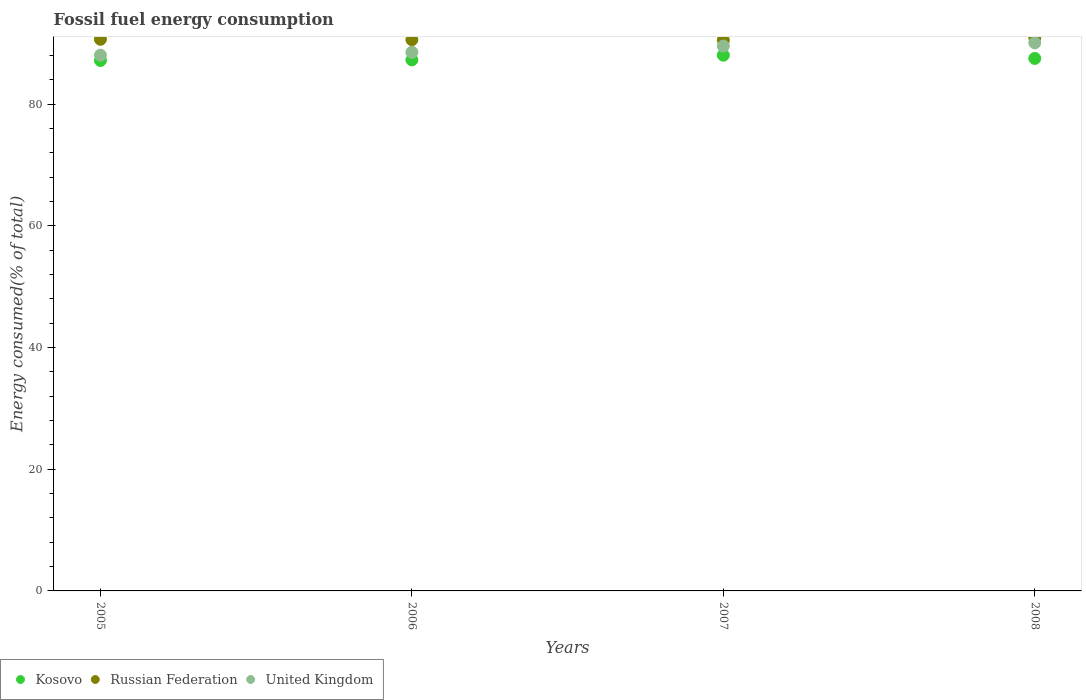Is the number of dotlines equal to the number of legend labels?
Give a very brief answer. Yes. What is the percentage of energy consumed in United Kingdom in 2008?
Your answer should be compact. 90.1. Across all years, what is the maximum percentage of energy consumed in Russian Federation?
Make the answer very short. 90.95. Across all years, what is the minimum percentage of energy consumed in Russian Federation?
Provide a short and direct response. 90.55. In which year was the percentage of energy consumed in United Kingdom maximum?
Offer a terse response. 2008. In which year was the percentage of energy consumed in Russian Federation minimum?
Keep it short and to the point. 2007. What is the total percentage of energy consumed in Russian Federation in the graph?
Ensure brevity in your answer.  362.81. What is the difference between the percentage of energy consumed in United Kingdom in 2005 and that in 2008?
Your answer should be compact. -2.03. What is the difference between the percentage of energy consumed in United Kingdom in 2006 and the percentage of energy consumed in Kosovo in 2007?
Keep it short and to the point. 0.47. What is the average percentage of energy consumed in Russian Federation per year?
Offer a terse response. 90.7. In the year 2005, what is the difference between the percentage of energy consumed in Russian Federation and percentage of energy consumed in Kosovo?
Your answer should be compact. 3.48. What is the ratio of the percentage of energy consumed in United Kingdom in 2006 to that in 2007?
Your response must be concise. 0.99. What is the difference between the highest and the second highest percentage of energy consumed in Russian Federation?
Your answer should be very brief. 0.26. What is the difference between the highest and the lowest percentage of energy consumed in Russian Federation?
Provide a succinct answer. 0.4. Is the sum of the percentage of energy consumed in United Kingdom in 2005 and 2007 greater than the maximum percentage of energy consumed in Kosovo across all years?
Make the answer very short. Yes. Is it the case that in every year, the sum of the percentage of energy consumed in Russian Federation and percentage of energy consumed in Kosovo  is greater than the percentage of energy consumed in United Kingdom?
Make the answer very short. Yes. Does the percentage of energy consumed in Russian Federation monotonically increase over the years?
Your answer should be compact. No. Is the percentage of energy consumed in United Kingdom strictly greater than the percentage of energy consumed in Russian Federation over the years?
Make the answer very short. No. Is the percentage of energy consumed in Kosovo strictly less than the percentage of energy consumed in Russian Federation over the years?
Keep it short and to the point. Yes. How many dotlines are there?
Make the answer very short. 3. How many years are there in the graph?
Your response must be concise. 4. Are the values on the major ticks of Y-axis written in scientific E-notation?
Give a very brief answer. No. How are the legend labels stacked?
Make the answer very short. Horizontal. What is the title of the graph?
Give a very brief answer. Fossil fuel energy consumption. Does "High income: OECD" appear as one of the legend labels in the graph?
Offer a terse response. No. What is the label or title of the Y-axis?
Offer a very short reply. Energy consumed(% of total). What is the Energy consumed(% of total) in Kosovo in 2005?
Your answer should be very brief. 87.21. What is the Energy consumed(% of total) in Russian Federation in 2005?
Keep it short and to the point. 90.69. What is the Energy consumed(% of total) of United Kingdom in 2005?
Provide a succinct answer. 88.08. What is the Energy consumed(% of total) of Kosovo in 2006?
Offer a very short reply. 87.3. What is the Energy consumed(% of total) in Russian Federation in 2006?
Give a very brief answer. 90.62. What is the Energy consumed(% of total) of United Kingdom in 2006?
Give a very brief answer. 88.55. What is the Energy consumed(% of total) in Kosovo in 2007?
Your answer should be compact. 88.07. What is the Energy consumed(% of total) of Russian Federation in 2007?
Your answer should be very brief. 90.55. What is the Energy consumed(% of total) of United Kingdom in 2007?
Your response must be concise. 89.58. What is the Energy consumed(% of total) in Kosovo in 2008?
Your answer should be very brief. 87.54. What is the Energy consumed(% of total) of Russian Federation in 2008?
Give a very brief answer. 90.95. What is the Energy consumed(% of total) of United Kingdom in 2008?
Your response must be concise. 90.1. Across all years, what is the maximum Energy consumed(% of total) of Kosovo?
Provide a short and direct response. 88.07. Across all years, what is the maximum Energy consumed(% of total) of Russian Federation?
Ensure brevity in your answer.  90.95. Across all years, what is the maximum Energy consumed(% of total) in United Kingdom?
Give a very brief answer. 90.1. Across all years, what is the minimum Energy consumed(% of total) in Kosovo?
Your response must be concise. 87.21. Across all years, what is the minimum Energy consumed(% of total) in Russian Federation?
Offer a very short reply. 90.55. Across all years, what is the minimum Energy consumed(% of total) in United Kingdom?
Make the answer very short. 88.08. What is the total Energy consumed(% of total) of Kosovo in the graph?
Ensure brevity in your answer.  350.12. What is the total Energy consumed(% of total) in Russian Federation in the graph?
Provide a short and direct response. 362.81. What is the total Energy consumed(% of total) in United Kingdom in the graph?
Offer a terse response. 356.3. What is the difference between the Energy consumed(% of total) in Kosovo in 2005 and that in 2006?
Ensure brevity in your answer.  -0.09. What is the difference between the Energy consumed(% of total) in Russian Federation in 2005 and that in 2006?
Offer a terse response. 0.07. What is the difference between the Energy consumed(% of total) of United Kingdom in 2005 and that in 2006?
Offer a terse response. -0.47. What is the difference between the Energy consumed(% of total) in Kosovo in 2005 and that in 2007?
Keep it short and to the point. -0.87. What is the difference between the Energy consumed(% of total) of Russian Federation in 2005 and that in 2007?
Make the answer very short. 0.14. What is the difference between the Energy consumed(% of total) in United Kingdom in 2005 and that in 2007?
Provide a succinct answer. -1.5. What is the difference between the Energy consumed(% of total) in Kosovo in 2005 and that in 2008?
Give a very brief answer. -0.33. What is the difference between the Energy consumed(% of total) of Russian Federation in 2005 and that in 2008?
Keep it short and to the point. -0.26. What is the difference between the Energy consumed(% of total) in United Kingdom in 2005 and that in 2008?
Offer a very short reply. -2.02. What is the difference between the Energy consumed(% of total) in Kosovo in 2006 and that in 2007?
Give a very brief answer. -0.77. What is the difference between the Energy consumed(% of total) in Russian Federation in 2006 and that in 2007?
Offer a very short reply. 0.07. What is the difference between the Energy consumed(% of total) in United Kingdom in 2006 and that in 2007?
Offer a terse response. -1.03. What is the difference between the Energy consumed(% of total) in Kosovo in 2006 and that in 2008?
Provide a succinct answer. -0.24. What is the difference between the Energy consumed(% of total) in Russian Federation in 2006 and that in 2008?
Give a very brief answer. -0.33. What is the difference between the Energy consumed(% of total) of United Kingdom in 2006 and that in 2008?
Your response must be concise. -1.55. What is the difference between the Energy consumed(% of total) of Kosovo in 2007 and that in 2008?
Provide a succinct answer. 0.53. What is the difference between the Energy consumed(% of total) in Russian Federation in 2007 and that in 2008?
Provide a succinct answer. -0.4. What is the difference between the Energy consumed(% of total) of United Kingdom in 2007 and that in 2008?
Keep it short and to the point. -0.53. What is the difference between the Energy consumed(% of total) of Kosovo in 2005 and the Energy consumed(% of total) of Russian Federation in 2006?
Ensure brevity in your answer.  -3.41. What is the difference between the Energy consumed(% of total) in Kosovo in 2005 and the Energy consumed(% of total) in United Kingdom in 2006?
Keep it short and to the point. -1.34. What is the difference between the Energy consumed(% of total) of Russian Federation in 2005 and the Energy consumed(% of total) of United Kingdom in 2006?
Your response must be concise. 2.14. What is the difference between the Energy consumed(% of total) in Kosovo in 2005 and the Energy consumed(% of total) in Russian Federation in 2007?
Make the answer very short. -3.34. What is the difference between the Energy consumed(% of total) in Kosovo in 2005 and the Energy consumed(% of total) in United Kingdom in 2007?
Your response must be concise. -2.37. What is the difference between the Energy consumed(% of total) in Russian Federation in 2005 and the Energy consumed(% of total) in United Kingdom in 2007?
Provide a succinct answer. 1.11. What is the difference between the Energy consumed(% of total) in Kosovo in 2005 and the Energy consumed(% of total) in Russian Federation in 2008?
Make the answer very short. -3.74. What is the difference between the Energy consumed(% of total) of Kosovo in 2005 and the Energy consumed(% of total) of United Kingdom in 2008?
Your answer should be very brief. -2.89. What is the difference between the Energy consumed(% of total) in Russian Federation in 2005 and the Energy consumed(% of total) in United Kingdom in 2008?
Keep it short and to the point. 0.59. What is the difference between the Energy consumed(% of total) in Kosovo in 2006 and the Energy consumed(% of total) in Russian Federation in 2007?
Provide a succinct answer. -3.25. What is the difference between the Energy consumed(% of total) in Kosovo in 2006 and the Energy consumed(% of total) in United Kingdom in 2007?
Your response must be concise. -2.28. What is the difference between the Energy consumed(% of total) of Russian Federation in 2006 and the Energy consumed(% of total) of United Kingdom in 2007?
Keep it short and to the point. 1.05. What is the difference between the Energy consumed(% of total) in Kosovo in 2006 and the Energy consumed(% of total) in Russian Federation in 2008?
Offer a terse response. -3.65. What is the difference between the Energy consumed(% of total) in Kosovo in 2006 and the Energy consumed(% of total) in United Kingdom in 2008?
Give a very brief answer. -2.8. What is the difference between the Energy consumed(% of total) in Russian Federation in 2006 and the Energy consumed(% of total) in United Kingdom in 2008?
Make the answer very short. 0.52. What is the difference between the Energy consumed(% of total) of Kosovo in 2007 and the Energy consumed(% of total) of Russian Federation in 2008?
Ensure brevity in your answer.  -2.87. What is the difference between the Energy consumed(% of total) of Kosovo in 2007 and the Energy consumed(% of total) of United Kingdom in 2008?
Make the answer very short. -2.03. What is the difference between the Energy consumed(% of total) of Russian Federation in 2007 and the Energy consumed(% of total) of United Kingdom in 2008?
Keep it short and to the point. 0.45. What is the average Energy consumed(% of total) in Kosovo per year?
Give a very brief answer. 87.53. What is the average Energy consumed(% of total) in Russian Federation per year?
Provide a succinct answer. 90.7. What is the average Energy consumed(% of total) of United Kingdom per year?
Offer a very short reply. 89.07. In the year 2005, what is the difference between the Energy consumed(% of total) of Kosovo and Energy consumed(% of total) of Russian Federation?
Your answer should be very brief. -3.48. In the year 2005, what is the difference between the Energy consumed(% of total) of Kosovo and Energy consumed(% of total) of United Kingdom?
Offer a terse response. -0.87. In the year 2005, what is the difference between the Energy consumed(% of total) in Russian Federation and Energy consumed(% of total) in United Kingdom?
Offer a terse response. 2.61. In the year 2006, what is the difference between the Energy consumed(% of total) in Kosovo and Energy consumed(% of total) in Russian Federation?
Make the answer very short. -3.32. In the year 2006, what is the difference between the Energy consumed(% of total) of Kosovo and Energy consumed(% of total) of United Kingdom?
Offer a very short reply. -1.25. In the year 2006, what is the difference between the Energy consumed(% of total) in Russian Federation and Energy consumed(% of total) in United Kingdom?
Your answer should be compact. 2.07. In the year 2007, what is the difference between the Energy consumed(% of total) in Kosovo and Energy consumed(% of total) in Russian Federation?
Provide a short and direct response. -2.48. In the year 2007, what is the difference between the Energy consumed(% of total) of Kosovo and Energy consumed(% of total) of United Kingdom?
Provide a succinct answer. -1.5. In the year 2007, what is the difference between the Energy consumed(% of total) of Russian Federation and Energy consumed(% of total) of United Kingdom?
Your answer should be compact. 0.97. In the year 2008, what is the difference between the Energy consumed(% of total) of Kosovo and Energy consumed(% of total) of Russian Federation?
Provide a succinct answer. -3.4. In the year 2008, what is the difference between the Energy consumed(% of total) in Kosovo and Energy consumed(% of total) in United Kingdom?
Offer a very short reply. -2.56. In the year 2008, what is the difference between the Energy consumed(% of total) of Russian Federation and Energy consumed(% of total) of United Kingdom?
Make the answer very short. 0.85. What is the ratio of the Energy consumed(% of total) in Kosovo in 2005 to that in 2006?
Provide a succinct answer. 1. What is the ratio of the Energy consumed(% of total) in Russian Federation in 2005 to that in 2006?
Your answer should be compact. 1. What is the ratio of the Energy consumed(% of total) of United Kingdom in 2005 to that in 2006?
Your answer should be very brief. 0.99. What is the ratio of the Energy consumed(% of total) of Kosovo in 2005 to that in 2007?
Give a very brief answer. 0.99. What is the ratio of the Energy consumed(% of total) in United Kingdom in 2005 to that in 2007?
Ensure brevity in your answer.  0.98. What is the ratio of the Energy consumed(% of total) of Kosovo in 2005 to that in 2008?
Your answer should be compact. 1. What is the ratio of the Energy consumed(% of total) in Russian Federation in 2005 to that in 2008?
Provide a short and direct response. 1. What is the ratio of the Energy consumed(% of total) in United Kingdom in 2005 to that in 2008?
Ensure brevity in your answer.  0.98. What is the ratio of the Energy consumed(% of total) in Russian Federation in 2006 to that in 2007?
Offer a very short reply. 1. What is the ratio of the Energy consumed(% of total) in Kosovo in 2006 to that in 2008?
Ensure brevity in your answer.  1. What is the ratio of the Energy consumed(% of total) in Russian Federation in 2006 to that in 2008?
Your answer should be very brief. 1. What is the ratio of the Energy consumed(% of total) of United Kingdom in 2006 to that in 2008?
Offer a very short reply. 0.98. What is the ratio of the Energy consumed(% of total) of Kosovo in 2007 to that in 2008?
Your answer should be compact. 1.01. What is the ratio of the Energy consumed(% of total) in Russian Federation in 2007 to that in 2008?
Your answer should be very brief. 1. What is the ratio of the Energy consumed(% of total) in United Kingdom in 2007 to that in 2008?
Your answer should be very brief. 0.99. What is the difference between the highest and the second highest Energy consumed(% of total) of Kosovo?
Give a very brief answer. 0.53. What is the difference between the highest and the second highest Energy consumed(% of total) in Russian Federation?
Give a very brief answer. 0.26. What is the difference between the highest and the second highest Energy consumed(% of total) of United Kingdom?
Your answer should be compact. 0.53. What is the difference between the highest and the lowest Energy consumed(% of total) of Kosovo?
Offer a terse response. 0.87. What is the difference between the highest and the lowest Energy consumed(% of total) of Russian Federation?
Your response must be concise. 0.4. What is the difference between the highest and the lowest Energy consumed(% of total) of United Kingdom?
Make the answer very short. 2.02. 